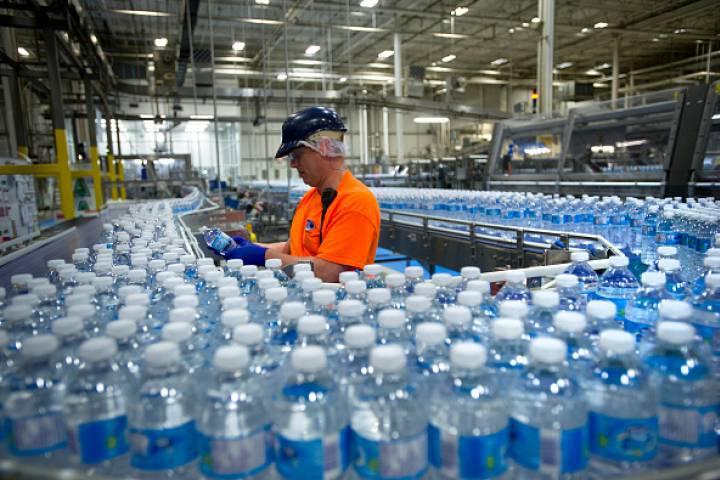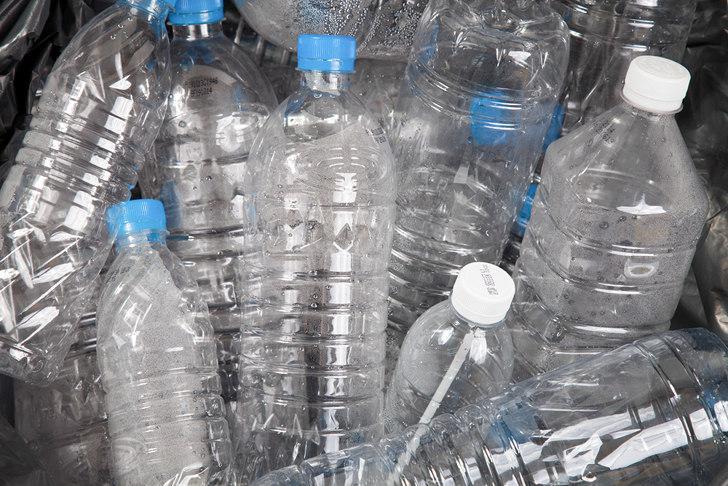The first image is the image on the left, the second image is the image on the right. Assess this claim about the two images: "At least one image shows all bottles with white caps.". Correct or not? Answer yes or no. Yes. 